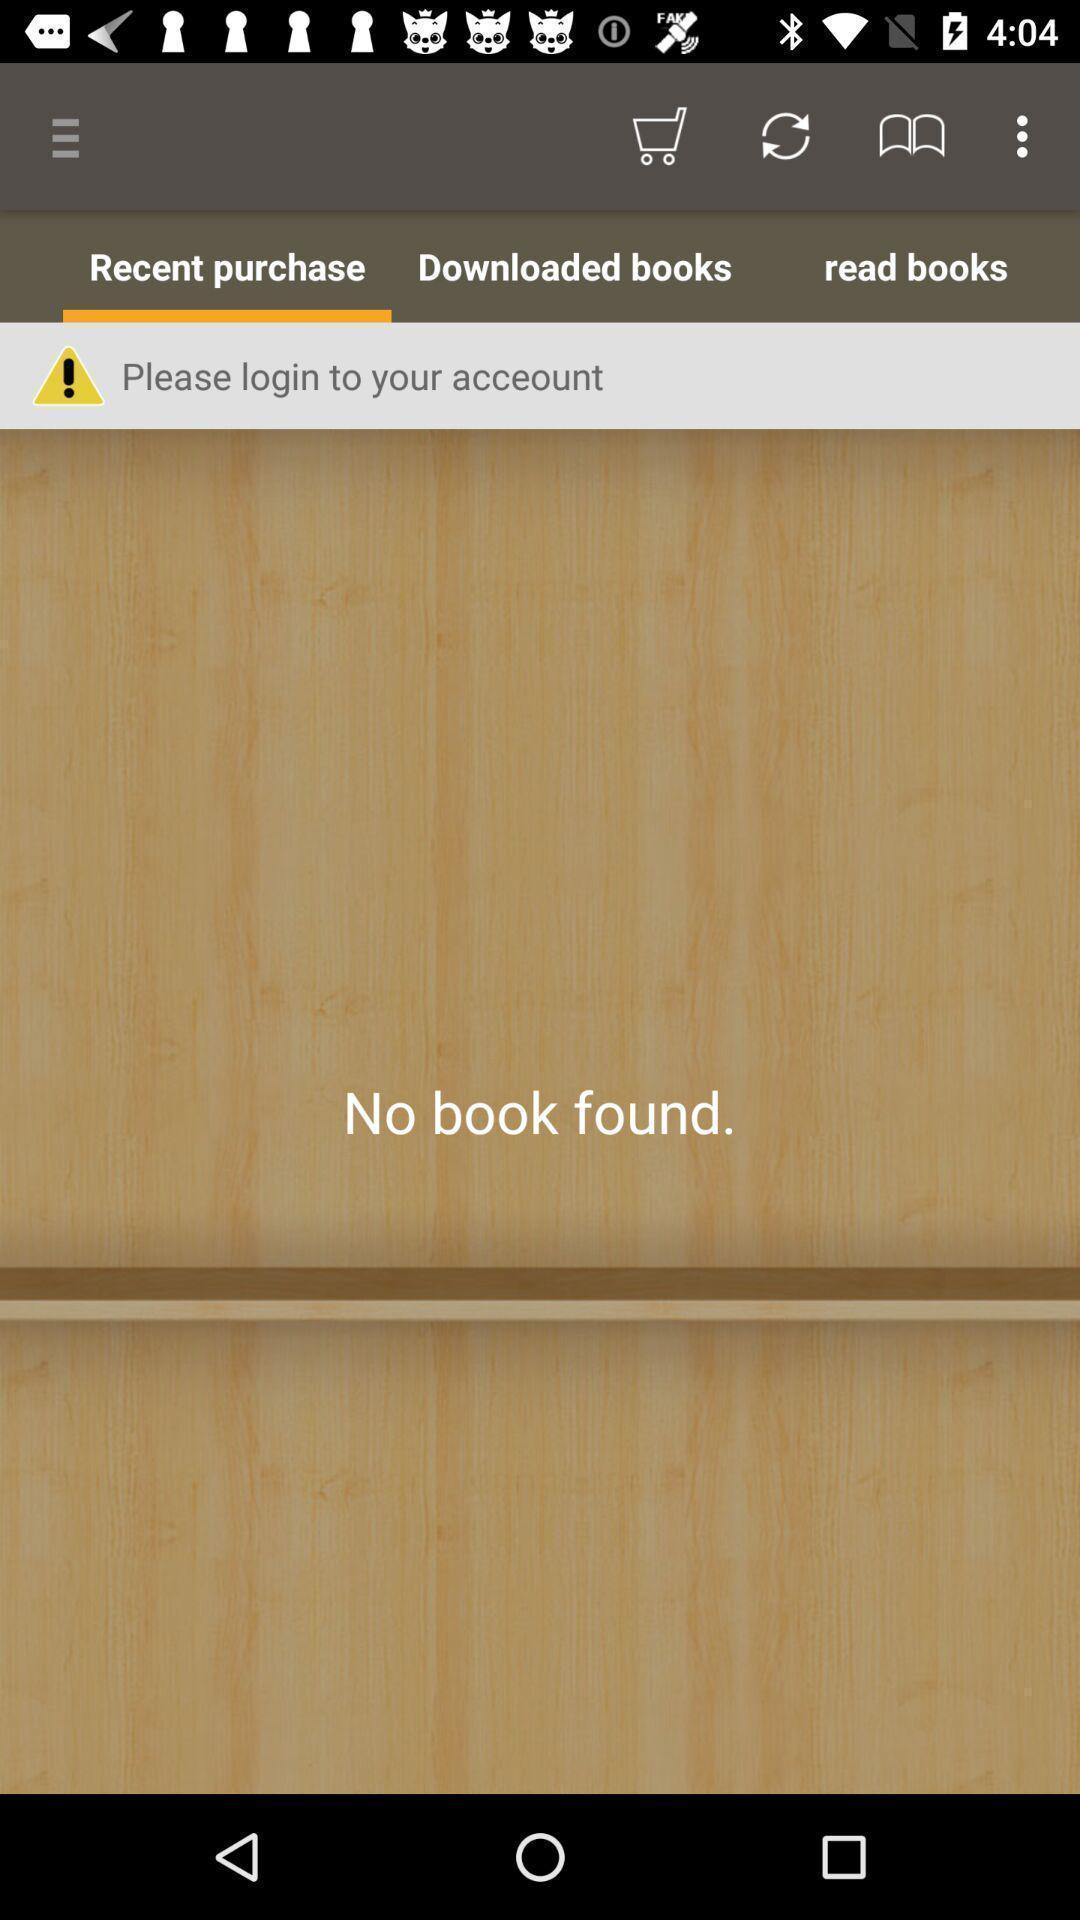Describe the key features of this screenshot. Screen showing no book found. 